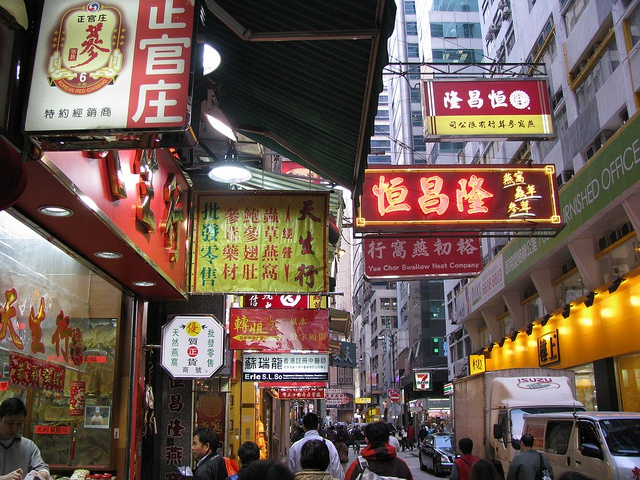Describe the objects in this image and their specific colors. I can see truck in olive, black, and gray tones, people in olive, black, gray, darkgray, and maroon tones, people in olive, black, brown, maroon, and gray tones, people in olive, black, maroon, and gray tones, and car in olive, black, gray, lightblue, and navy tones in this image. 